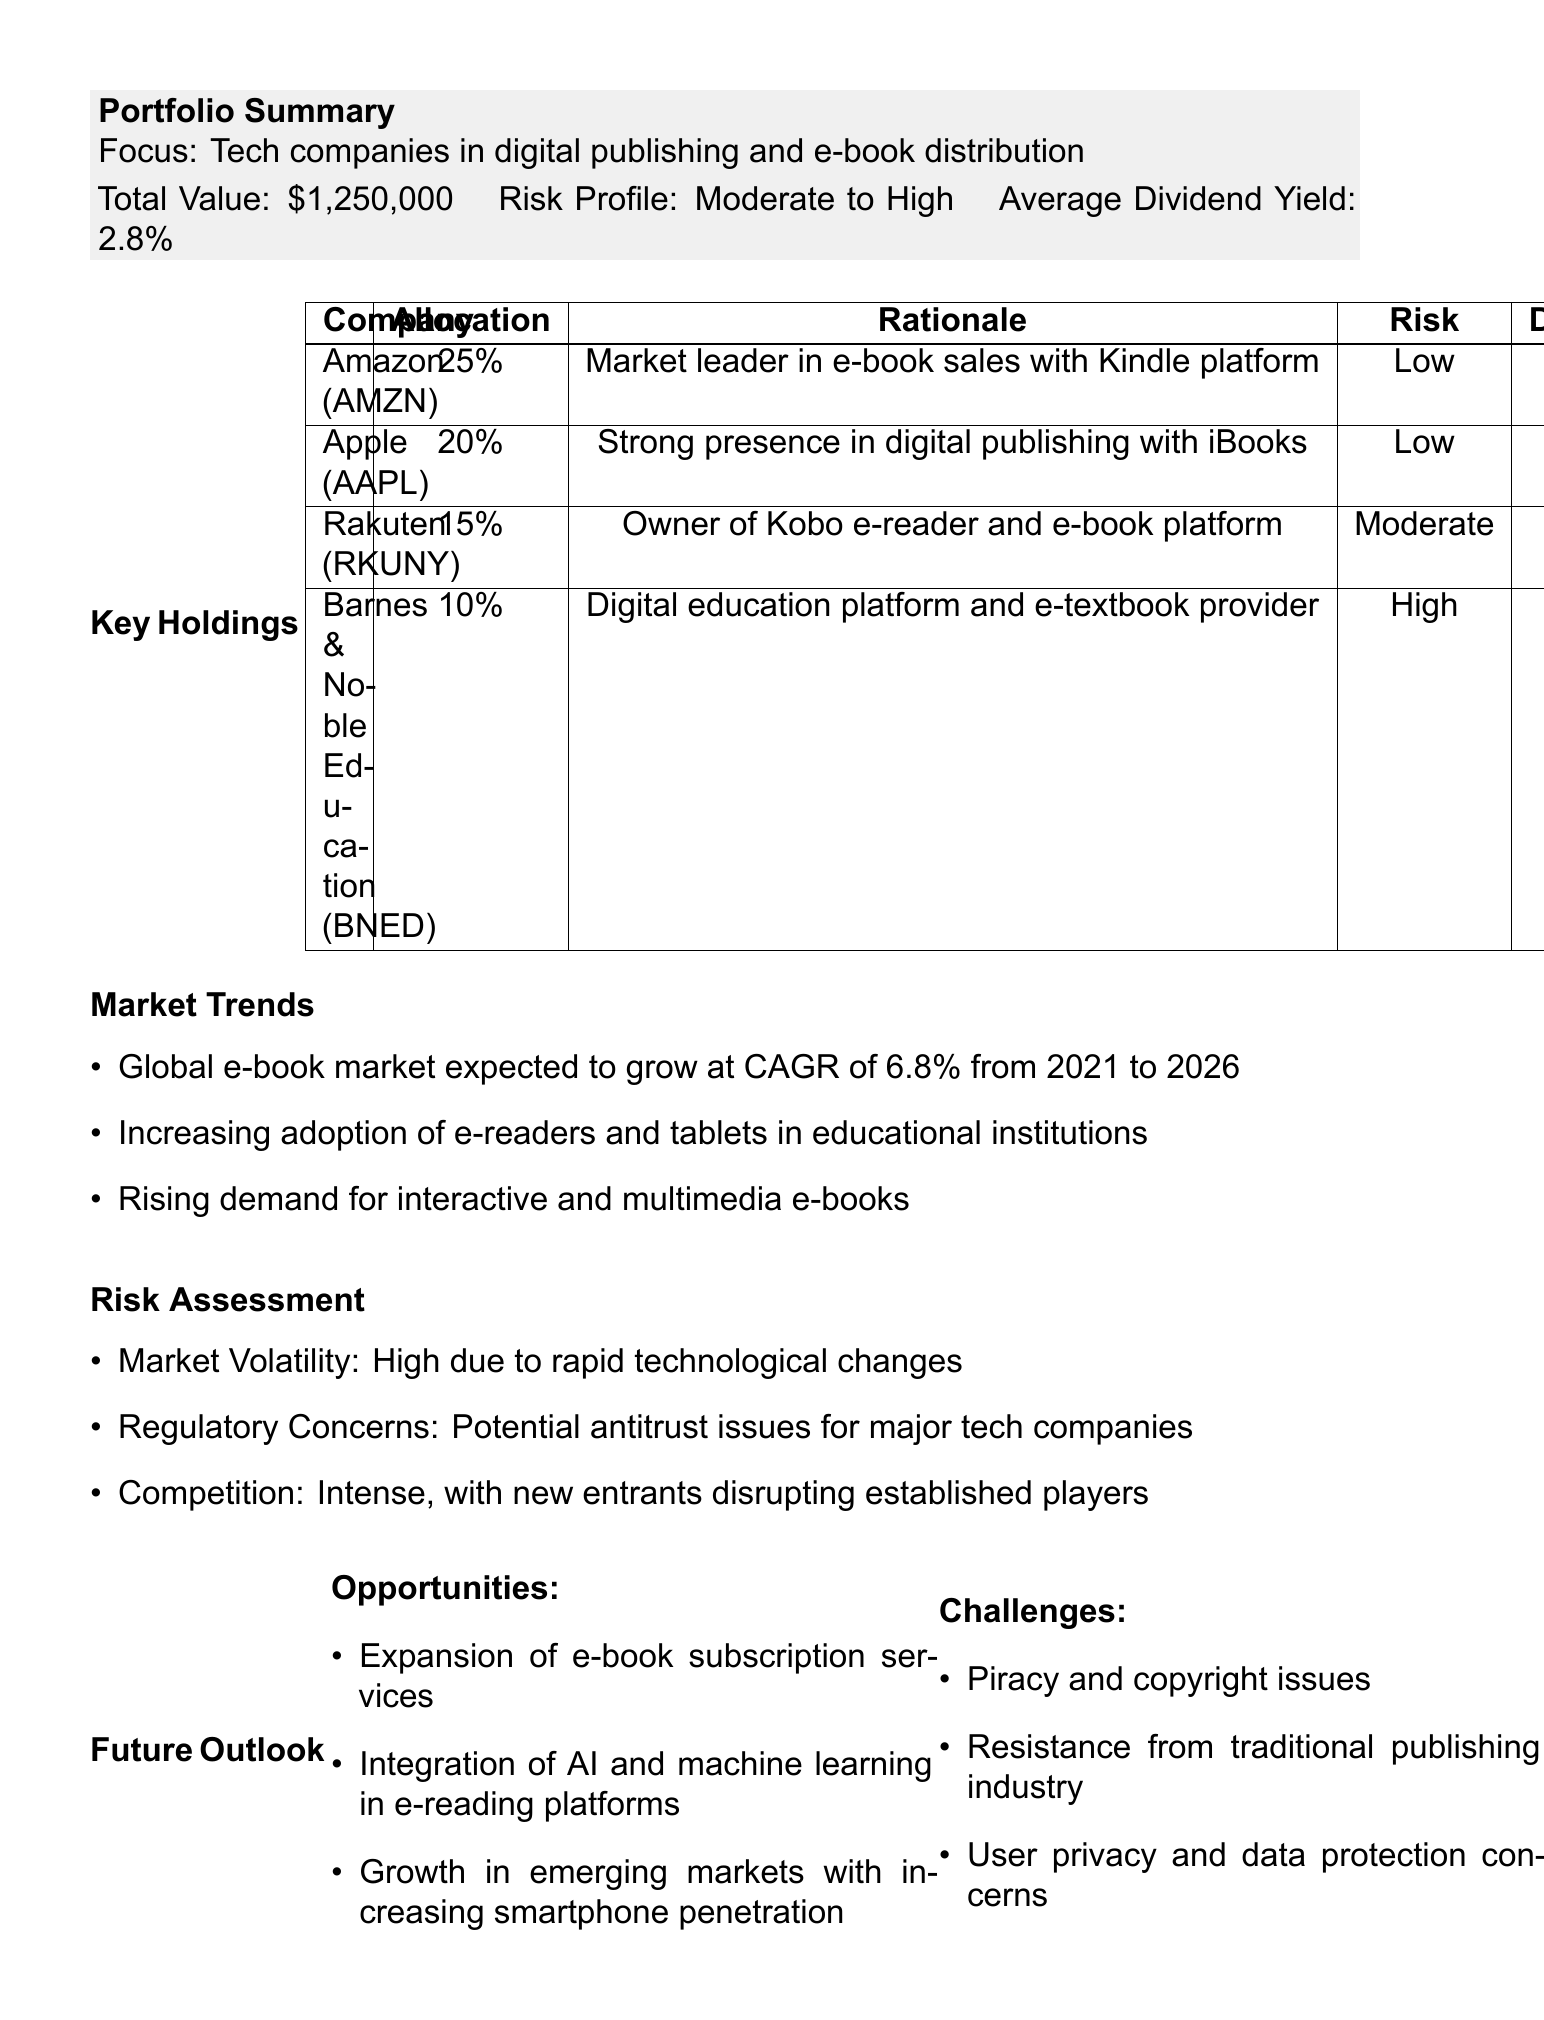what is the total value of the portfolio? The total value of the portfolio is explicitly stated in the document as $1,250,000.
Answer: $1,250,000 what is the average dividend yield? The document specifies that the average dividend yield for the portfolio is 2.8%.
Answer: 2.8% which company has the highest allocation in the portfolio? The allocation for Amazon is 25%, which is the highest among the key holdings listed.
Answer: Amazon what is the risk profile of the investment portfolio? The risk profile is summarized in the document as Moderate to High.
Answer: Moderate to High how much of the portfolio is allocated to Rakuten? The document shows that Rakuten has an allocation of 15% in the portfolio.
Answer: 15% what risks are highlighted in the risk assessment section? The risk assessment mentions market volatility, regulatory concerns, and competition as key risks.
Answer: High due to rapid technological changes; Potential antitrust issues for major tech companies; Intense, with new entrants disrupting established players what opportunities does the future outlook section identify? The document outlines opportunities including expansion of e-book subscription services, integration of AI, and growth in emerging markets.
Answer: Expansion of e-book subscription services; Integration of AI and machine learning in e-reading platforms; Growth in emerging markets with increasing smartphone penetration which company is mentioned as a digital education platform? Barnes & Noble Education is identified in the document as a digital education platform and e-textbook provider.
Answer: Barnes & Noble Education what is the rationale for including Amazon in the portfolio? The rationale given for Amazon is that it is the market leader in e-book sales with the Kindle platform.
Answer: Market leader in e-book sales with Kindle platform 